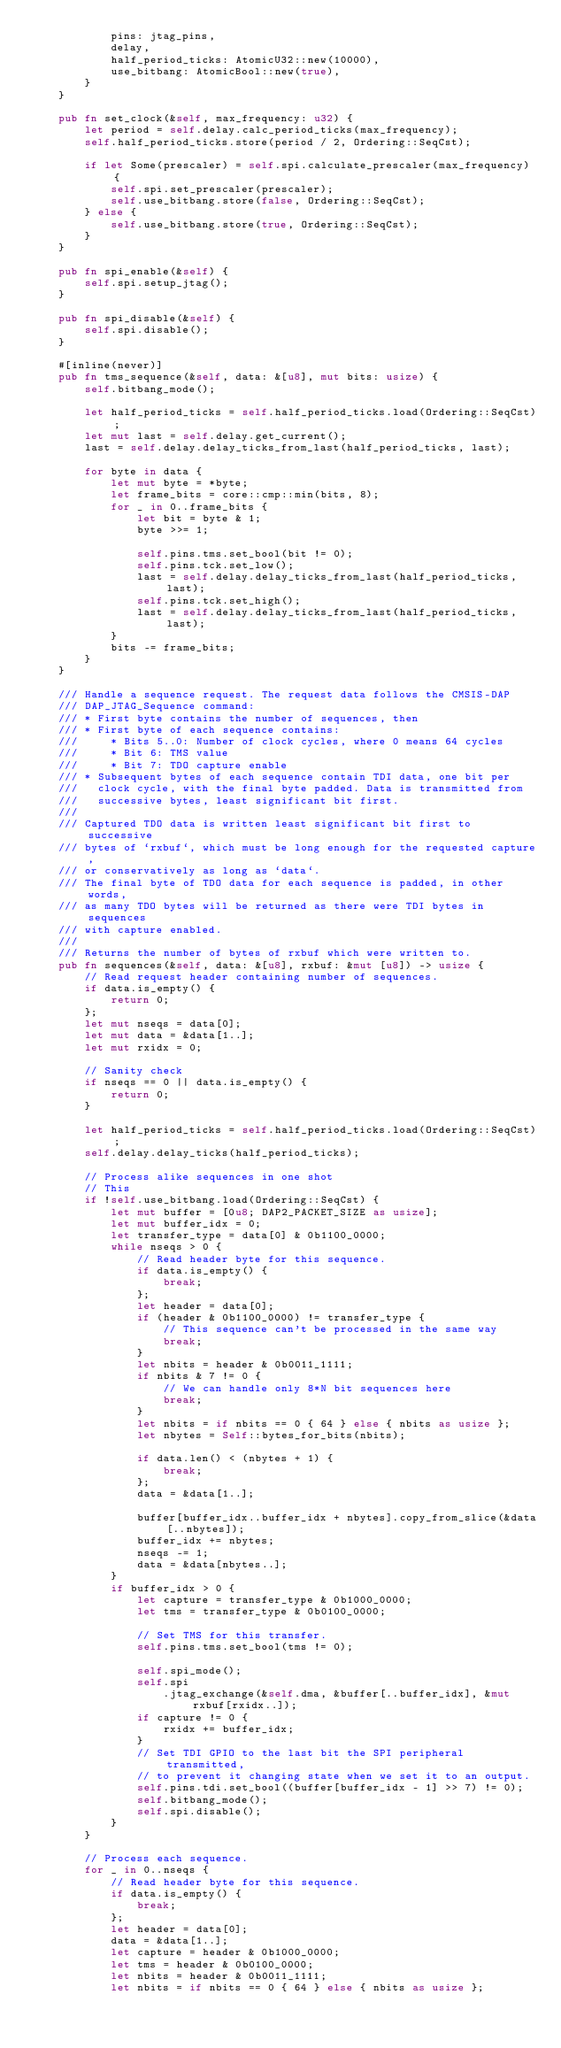Convert code to text. <code><loc_0><loc_0><loc_500><loc_500><_Rust_>            pins: jtag_pins,
            delay,
            half_period_ticks: AtomicU32::new(10000),
            use_bitbang: AtomicBool::new(true),
        }
    }

    pub fn set_clock(&self, max_frequency: u32) {
        let period = self.delay.calc_period_ticks(max_frequency);
        self.half_period_ticks.store(period / 2, Ordering::SeqCst);

        if let Some(prescaler) = self.spi.calculate_prescaler(max_frequency) {
            self.spi.set_prescaler(prescaler);
            self.use_bitbang.store(false, Ordering::SeqCst);
        } else {
            self.use_bitbang.store(true, Ordering::SeqCst);
        }
    }

    pub fn spi_enable(&self) {
        self.spi.setup_jtag();
    }

    pub fn spi_disable(&self) {
        self.spi.disable();
    }

    #[inline(never)]
    pub fn tms_sequence(&self, data: &[u8], mut bits: usize) {
        self.bitbang_mode();

        let half_period_ticks = self.half_period_ticks.load(Ordering::SeqCst);
        let mut last = self.delay.get_current();
        last = self.delay.delay_ticks_from_last(half_period_ticks, last);

        for byte in data {
            let mut byte = *byte;
            let frame_bits = core::cmp::min(bits, 8);
            for _ in 0..frame_bits {
                let bit = byte & 1;
                byte >>= 1;

                self.pins.tms.set_bool(bit != 0);
                self.pins.tck.set_low();
                last = self.delay.delay_ticks_from_last(half_period_ticks, last);
                self.pins.tck.set_high();
                last = self.delay.delay_ticks_from_last(half_period_ticks, last);
            }
            bits -= frame_bits;
        }
    }

    /// Handle a sequence request. The request data follows the CMSIS-DAP
    /// DAP_JTAG_Sequence command:
    /// * First byte contains the number of sequences, then
    /// * First byte of each sequence contains:
    ///     * Bits 5..0: Number of clock cycles, where 0 means 64 cycles
    ///     * Bit 6: TMS value
    ///     * Bit 7: TDO capture enable
    /// * Subsequent bytes of each sequence contain TDI data, one bit per
    ///   clock cycle, with the final byte padded. Data is transmitted from
    ///   successive bytes, least significant bit first.
    ///
    /// Captured TDO data is written least significant bit first to successive
    /// bytes of `rxbuf`, which must be long enough for the requested capture,
    /// or conservatively as long as `data`.
    /// The final byte of TDO data for each sequence is padded, in other words,
    /// as many TDO bytes will be returned as there were TDI bytes in sequences
    /// with capture enabled.
    ///
    /// Returns the number of bytes of rxbuf which were written to.
    pub fn sequences(&self, data: &[u8], rxbuf: &mut [u8]) -> usize {
        // Read request header containing number of sequences.
        if data.is_empty() {
            return 0;
        };
        let mut nseqs = data[0];
        let mut data = &data[1..];
        let mut rxidx = 0;

        // Sanity check
        if nseqs == 0 || data.is_empty() {
            return 0;
        }

        let half_period_ticks = self.half_period_ticks.load(Ordering::SeqCst);
        self.delay.delay_ticks(half_period_ticks);

        // Process alike sequences in one shot
        // This
        if !self.use_bitbang.load(Ordering::SeqCst) {
            let mut buffer = [0u8; DAP2_PACKET_SIZE as usize];
            let mut buffer_idx = 0;
            let transfer_type = data[0] & 0b1100_0000;
            while nseqs > 0 {
                // Read header byte for this sequence.
                if data.is_empty() {
                    break;
                };
                let header = data[0];
                if (header & 0b1100_0000) != transfer_type {
                    // This sequence can't be processed in the same way
                    break;
                }
                let nbits = header & 0b0011_1111;
                if nbits & 7 != 0 {
                    // We can handle only 8*N bit sequences here
                    break;
                }
                let nbits = if nbits == 0 { 64 } else { nbits as usize };
                let nbytes = Self::bytes_for_bits(nbits);

                if data.len() < (nbytes + 1) {
                    break;
                };
                data = &data[1..];

                buffer[buffer_idx..buffer_idx + nbytes].copy_from_slice(&data[..nbytes]);
                buffer_idx += nbytes;
                nseqs -= 1;
                data = &data[nbytes..];
            }
            if buffer_idx > 0 {
                let capture = transfer_type & 0b1000_0000;
                let tms = transfer_type & 0b0100_0000;

                // Set TMS for this transfer.
                self.pins.tms.set_bool(tms != 0);

                self.spi_mode();
                self.spi
                    .jtag_exchange(&self.dma, &buffer[..buffer_idx], &mut rxbuf[rxidx..]);
                if capture != 0 {
                    rxidx += buffer_idx;
                }
                // Set TDI GPIO to the last bit the SPI peripheral transmitted,
                // to prevent it changing state when we set it to an output.
                self.pins.tdi.set_bool((buffer[buffer_idx - 1] >> 7) != 0);
                self.bitbang_mode();
                self.spi.disable();
            }
        }

        // Process each sequence.
        for _ in 0..nseqs {
            // Read header byte for this sequence.
            if data.is_empty() {
                break;
            };
            let header = data[0];
            data = &data[1..];
            let capture = header & 0b1000_0000;
            let tms = header & 0b0100_0000;
            let nbits = header & 0b0011_1111;
            let nbits = if nbits == 0 { 64 } else { nbits as usize };</code> 